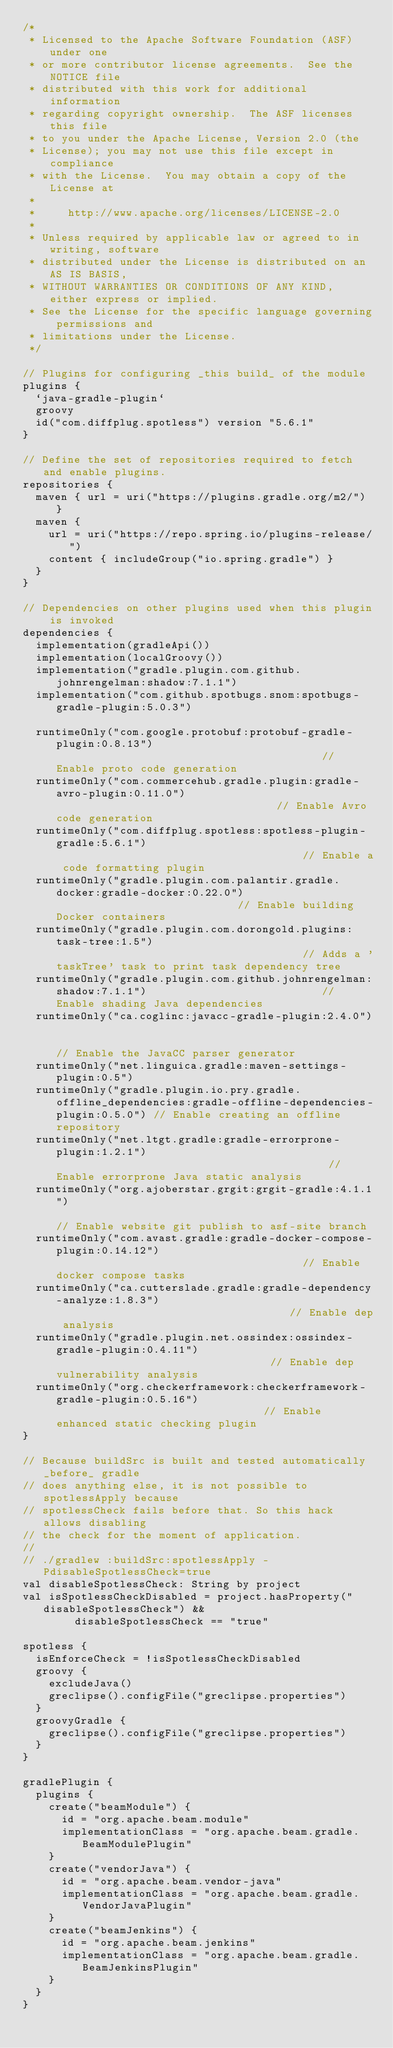Convert code to text. <code><loc_0><loc_0><loc_500><loc_500><_Kotlin_>/*
 * Licensed to the Apache Software Foundation (ASF) under one
 * or more contributor license agreements.  See the NOTICE file
 * distributed with this work for additional information
 * regarding copyright ownership.  The ASF licenses this file
 * to you under the Apache License, Version 2.0 (the
 * License); you may not use this file except in compliance
 * with the License.  You may obtain a copy of the License at
 *
 *     http://www.apache.org/licenses/LICENSE-2.0
 *
 * Unless required by applicable law or agreed to in writing, software
 * distributed under the License is distributed on an AS IS BASIS,
 * WITHOUT WARRANTIES OR CONDITIONS OF ANY KIND, either express or implied.
 * See the License for the specific language governing permissions and
 * limitations under the License.
 */

// Plugins for configuring _this build_ of the module
plugins {
  `java-gradle-plugin`
  groovy
  id("com.diffplug.spotless") version "5.6.1"
}

// Define the set of repositories required to fetch and enable plugins.
repositories {
  maven { url = uri("https://plugins.gradle.org/m2/") }
  maven {
    url = uri("https://repo.spring.io/plugins-release/")
    content { includeGroup("io.spring.gradle") }
  }
}

// Dependencies on other plugins used when this plugin is invoked
dependencies {
  implementation(gradleApi())
  implementation(localGroovy())
  implementation("gradle.plugin.com.github.johnrengelman:shadow:7.1.1")
  implementation("com.github.spotbugs.snom:spotbugs-gradle-plugin:5.0.3")

  runtimeOnly("com.google.protobuf:protobuf-gradle-plugin:0.8.13")                                          // Enable proto code generation
  runtimeOnly("com.commercehub.gradle.plugin:gradle-avro-plugin:0.11.0")                                   // Enable Avro code generation
  runtimeOnly("com.diffplug.spotless:spotless-plugin-gradle:5.6.1")                                       // Enable a code formatting plugin
  runtimeOnly("gradle.plugin.com.palantir.gradle.docker:gradle-docker:0.22.0")                             // Enable building Docker containers
  runtimeOnly("gradle.plugin.com.dorongold.plugins:task-tree:1.5")                                       // Adds a 'taskTree' task to print task dependency tree
  runtimeOnly("gradle.plugin.com.github.johnrengelman:shadow:7.1.1")                           // Enable shading Java dependencies
  runtimeOnly("ca.coglinc:javacc-gradle-plugin:2.4.0")                                                     // Enable the JavaCC parser generator
  runtimeOnly("net.linguica.gradle:maven-settings-plugin:0.5")
  runtimeOnly("gradle.plugin.io.pry.gradle.offline_dependencies:gradle-offline-dependencies-plugin:0.5.0") // Enable creating an offline repository
  runtimeOnly("net.ltgt.gradle:gradle-errorprone-plugin:1.2.1")                                           // Enable errorprone Java static analysis
  runtimeOnly("org.ajoberstar.grgit:grgit-gradle:4.1.1")                                                   // Enable website git publish to asf-site branch
  runtimeOnly("com.avast.gradle:gradle-docker-compose-plugin:0.14.12")                                       // Enable docker compose tasks
  runtimeOnly("ca.cutterslade.gradle:gradle-dependency-analyze:1.8.3")                                     // Enable dep analysis
  runtimeOnly("gradle.plugin.net.ossindex:ossindex-gradle-plugin:0.4.11")                                  // Enable dep vulnerability analysis
  runtimeOnly("org.checkerframework:checkerframework-gradle-plugin:0.5.16")                                 // Enable enhanced static checking plugin
}

// Because buildSrc is built and tested automatically _before_ gradle
// does anything else, it is not possible to spotlessApply because
// spotlessCheck fails before that. So this hack allows disabling
// the check for the moment of application.
//
// ./gradlew :buildSrc:spotlessApply -PdisableSpotlessCheck=true
val disableSpotlessCheck: String by project
val isSpotlessCheckDisabled = project.hasProperty("disableSpotlessCheck") &&
        disableSpotlessCheck == "true"

spotless {
  isEnforceCheck = !isSpotlessCheckDisabled
  groovy {
    excludeJava()
    greclipse().configFile("greclipse.properties")
  }
  groovyGradle {
    greclipse().configFile("greclipse.properties")
  }
}

gradlePlugin {
  plugins {
    create("beamModule") {
      id = "org.apache.beam.module"
      implementationClass = "org.apache.beam.gradle.BeamModulePlugin"
    }
    create("vendorJava") {
      id = "org.apache.beam.vendor-java"
      implementationClass = "org.apache.beam.gradle.VendorJavaPlugin"
    }
    create("beamJenkins") {
      id = "org.apache.beam.jenkins"
      implementationClass = "org.apache.beam.gradle.BeamJenkinsPlugin"
    }
  }
}
</code> 